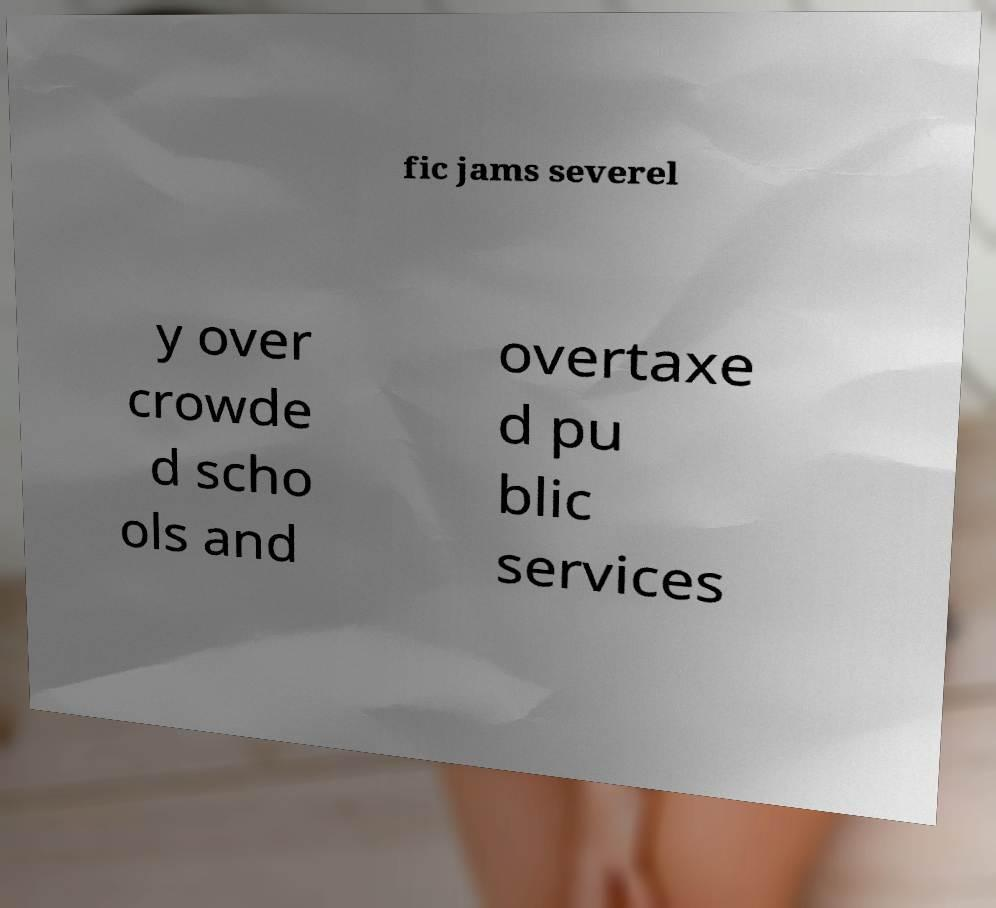For documentation purposes, I need the text within this image transcribed. Could you provide that? fic jams severel y over crowde d scho ols and overtaxe d pu blic services 